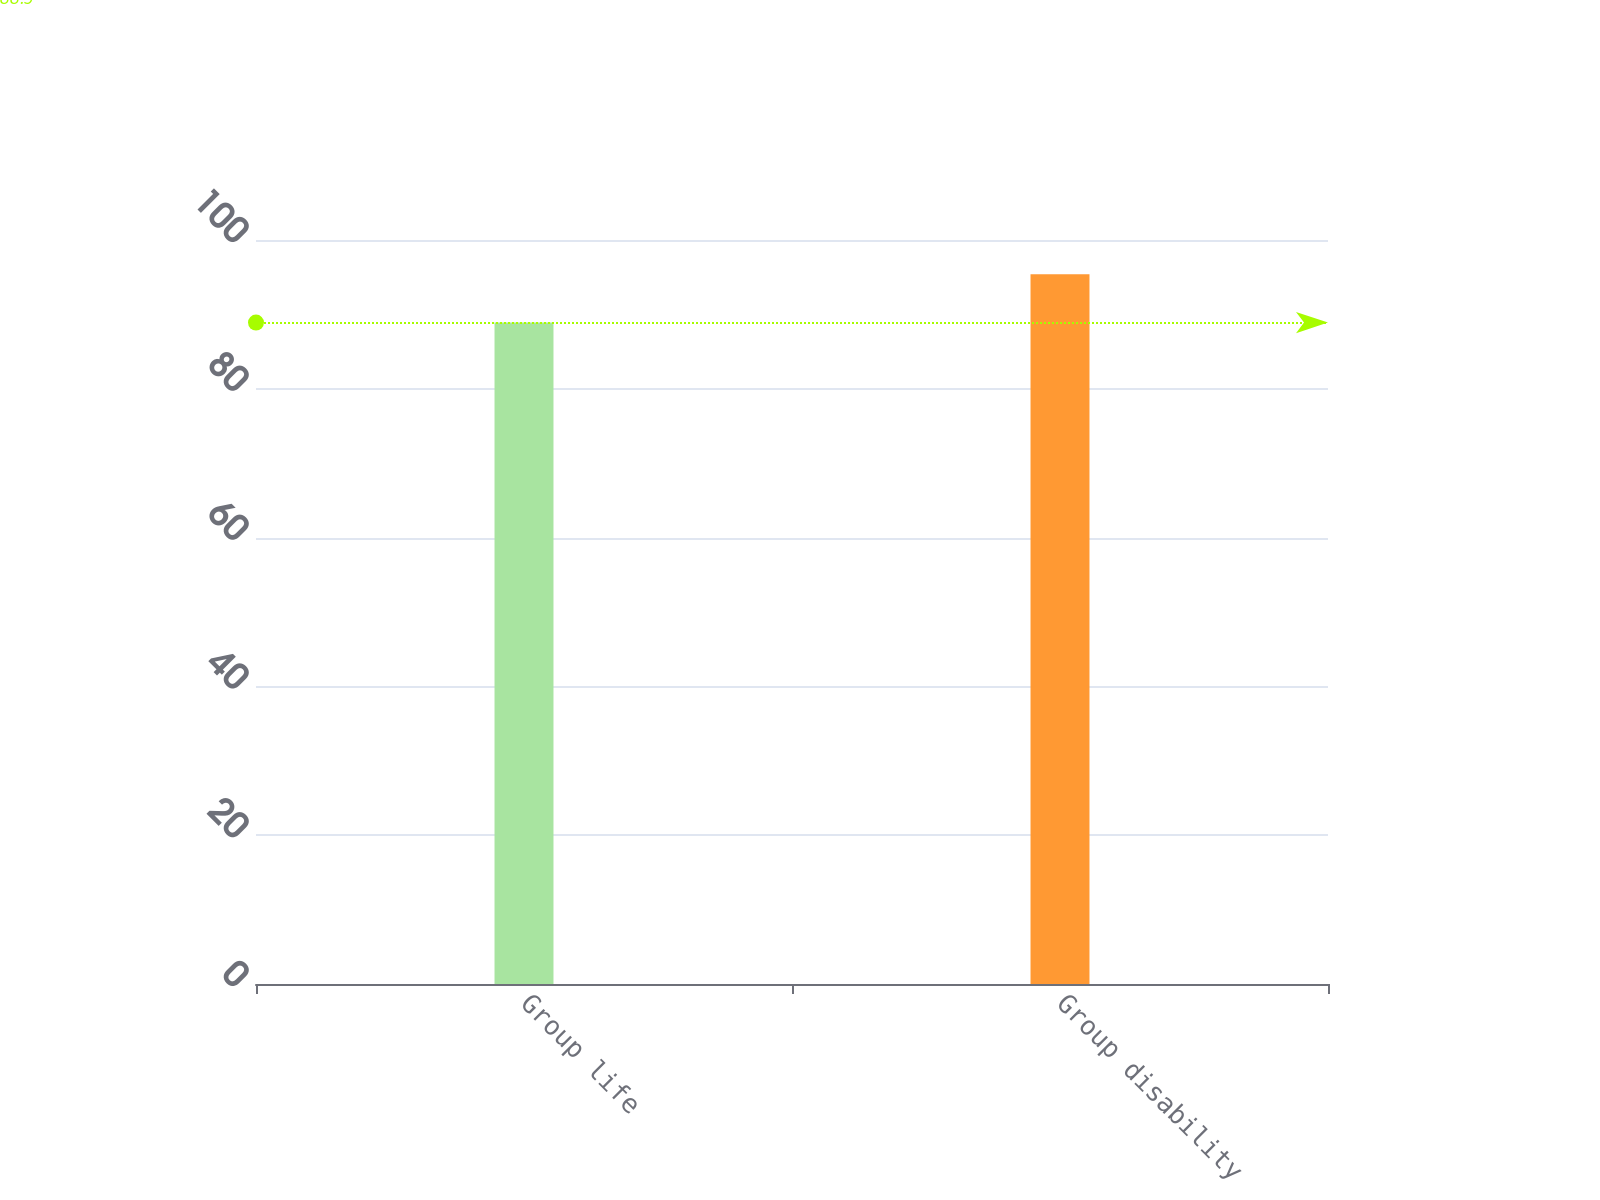Convert chart. <chart><loc_0><loc_0><loc_500><loc_500><bar_chart><fcel>Group life<fcel>Group disability<nl><fcel>88.9<fcel>95.4<nl></chart> 